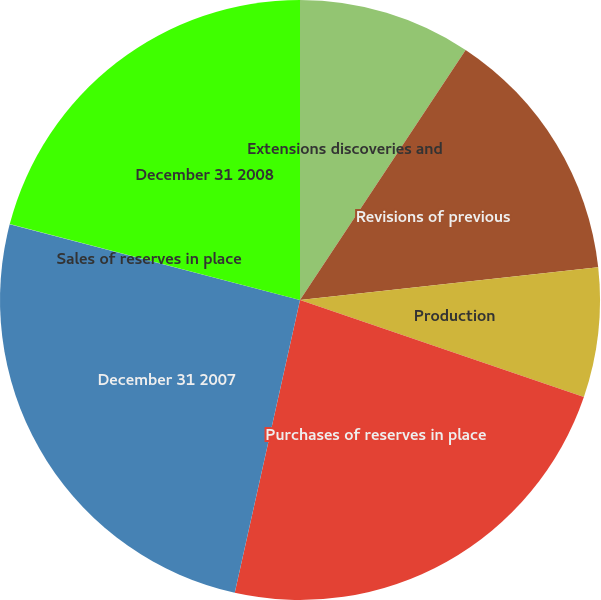<chart> <loc_0><loc_0><loc_500><loc_500><pie_chart><fcel>Extensions discoveries and<fcel>Revisions of previous<fcel>Production<fcel>Purchases of reserves in place<fcel>December 31 2007<fcel>Sales of reserves in place<fcel>December 31 2008<nl><fcel>9.31%<fcel>13.95%<fcel>6.98%<fcel>23.25%<fcel>25.57%<fcel>0.01%<fcel>20.93%<nl></chart> 